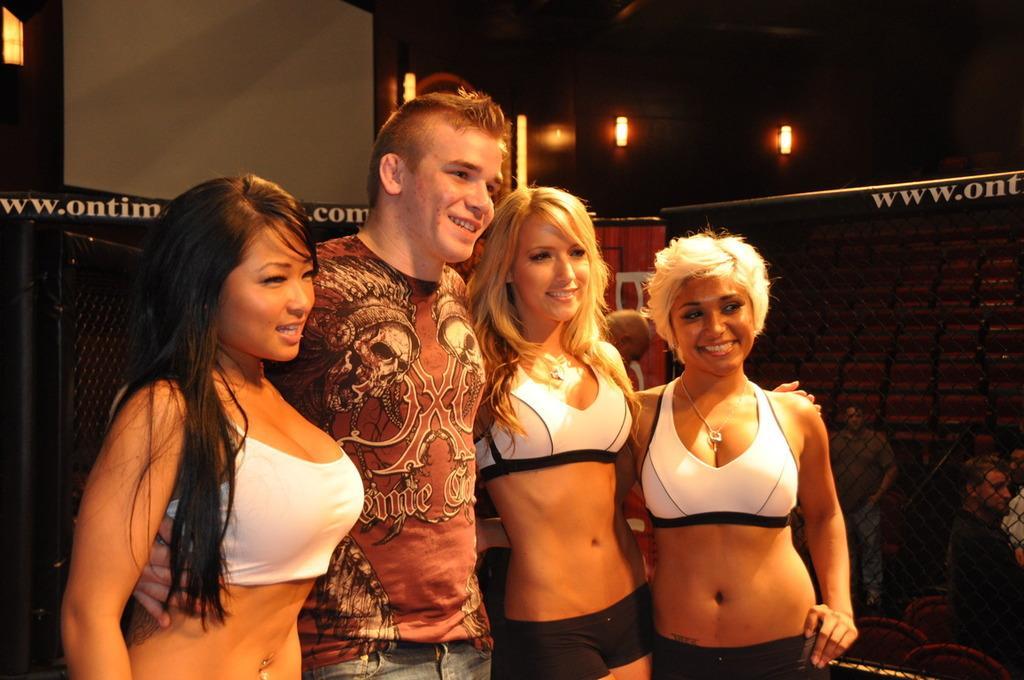How would you summarize this image in a sentence or two? In this image there is a person standing. Right side there are few persons behind the fence. Few lights are attached to the wall. Left side there is a fence. 